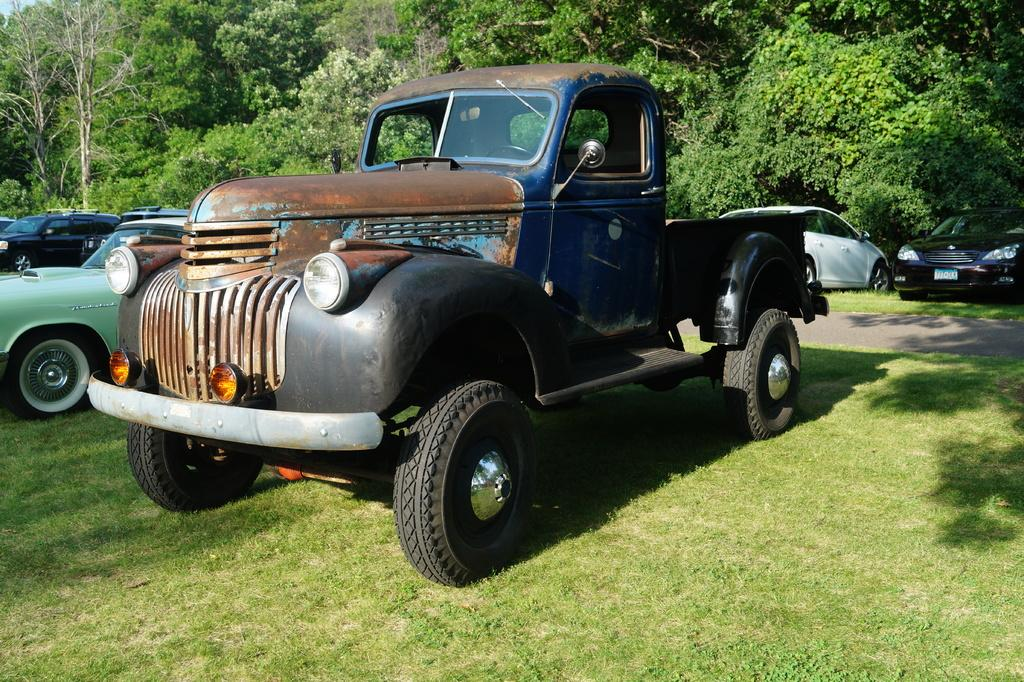What type of vehicles can be seen in the image? There are vehicles on a grassland in the image. What is visible in the background of the image? There is a road and trees visible in the background of the image. What type of elbow can be seen in the image? There is no elbow present in the image. 